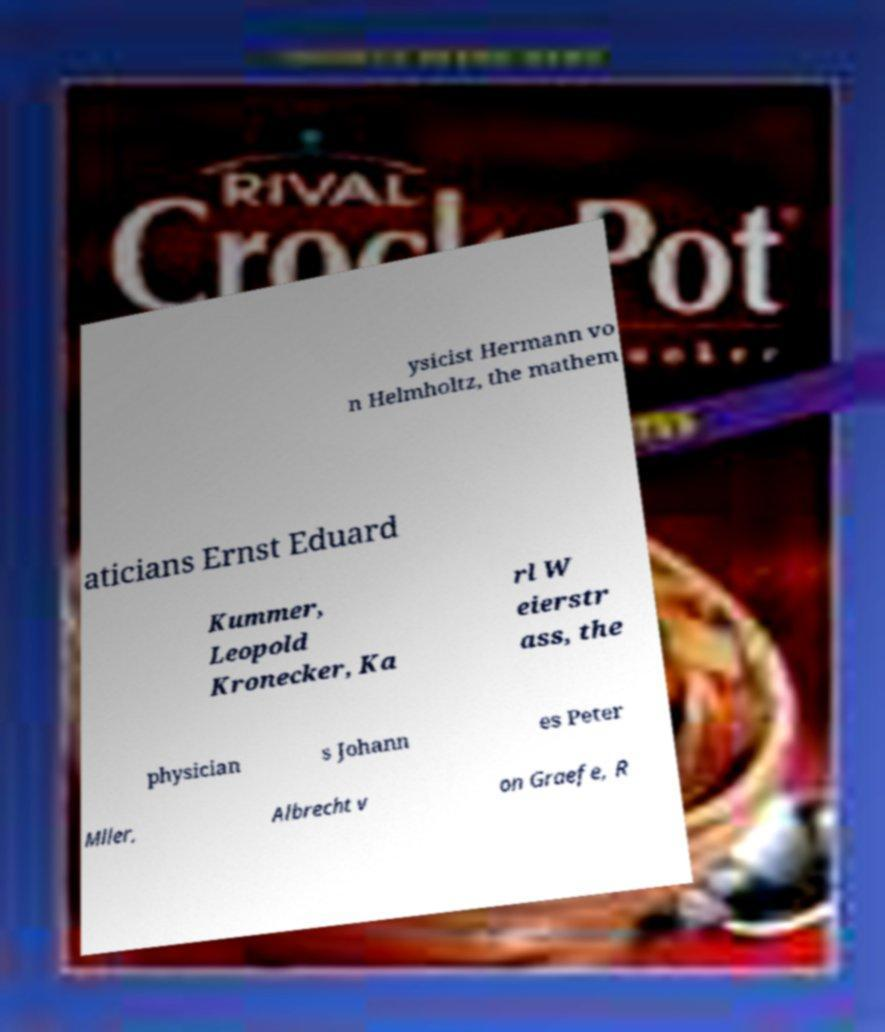For documentation purposes, I need the text within this image transcribed. Could you provide that? ysicist Hermann vo n Helmholtz, the mathem aticians Ernst Eduard Kummer, Leopold Kronecker, Ka rl W eierstr ass, the physician s Johann es Peter Mller, Albrecht v on Graefe, R 